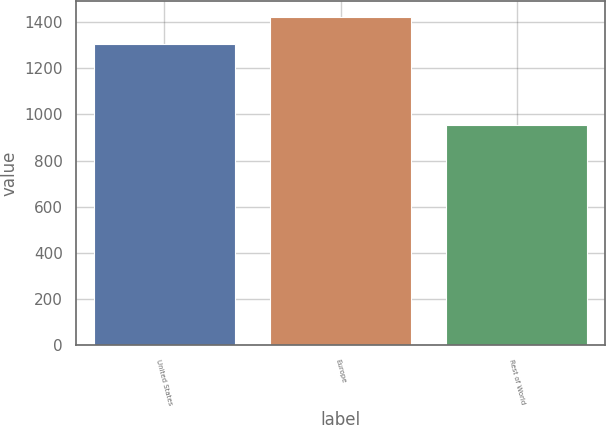Convert chart. <chart><loc_0><loc_0><loc_500><loc_500><bar_chart><fcel>United States<fcel>Europe<fcel>Rest of World<nl><fcel>1306.4<fcel>1421.7<fcel>952.9<nl></chart> 